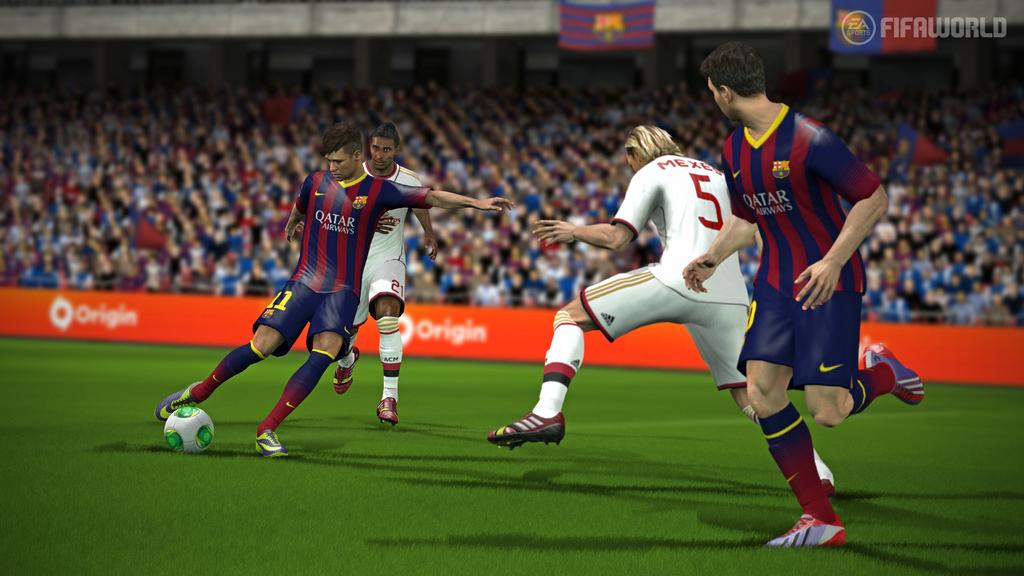What does it say on the orange ring around the stadium?
Make the answer very short. Origin. Which country do the players in blue and red stripes represent?
Give a very brief answer. Qatar. 